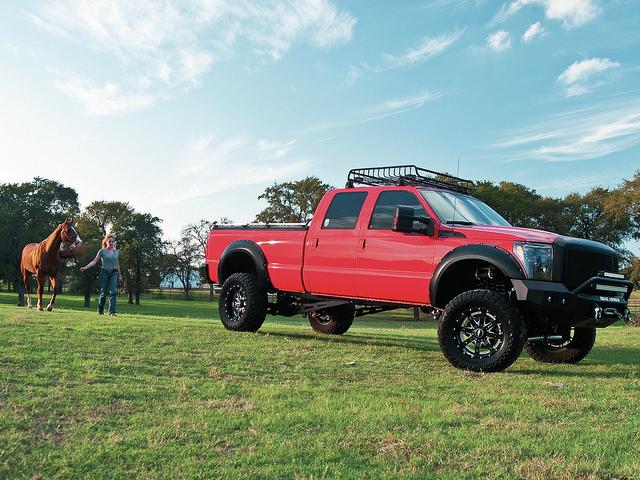What is the woman using to lead the horse?
Give a very brief answer. Rope. These trucks have four wheel drive?
Be succinct. Yes. What is attached to the front of the truck?
Quick response, please. Bumper. How many wheels do this vehicle have?
Concise answer only. 4. Is this a brand new truck?
Answer briefly. Yes. Does this truck have its own water source?
Short answer required. No. What does the apparatus on the front of the truck do?
Give a very brief answer. Tow. What type of clouds are in the sky?
Be succinct. Cumulus. 